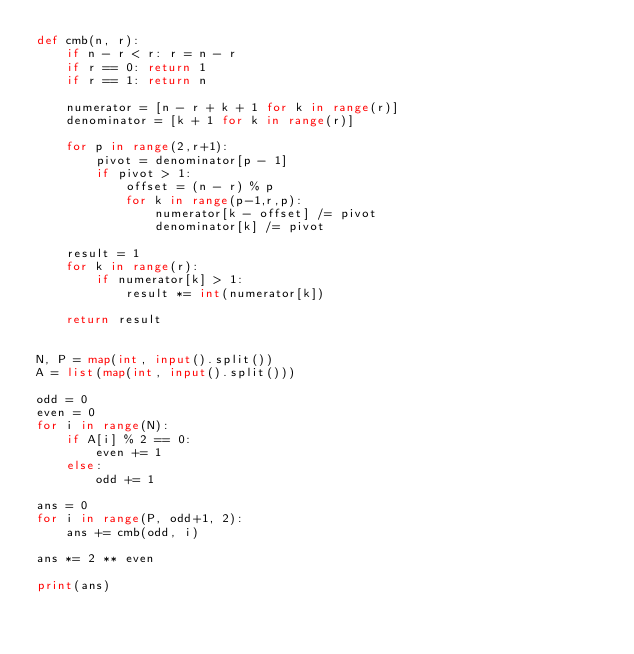Convert code to text. <code><loc_0><loc_0><loc_500><loc_500><_Python_>def cmb(n, r):
    if n - r < r: r = n - r
    if r == 0: return 1
    if r == 1: return n

    numerator = [n - r + k + 1 for k in range(r)]
    denominator = [k + 1 for k in range(r)]

    for p in range(2,r+1):
        pivot = denominator[p - 1]
        if pivot > 1:
            offset = (n - r) % p
            for k in range(p-1,r,p):
                numerator[k - offset] /= pivot
                denominator[k] /= pivot

    result = 1
    for k in range(r):
        if numerator[k] > 1:
            result *= int(numerator[k])

    return result


N, P = map(int, input().split())
A = list(map(int, input().split()))

odd = 0
even = 0
for i in range(N):
    if A[i] % 2 == 0:
        even += 1
    else:
        odd += 1
        
ans = 0
for i in range(P, odd+1, 2):
    ans += cmb(odd, i)
    
ans *= 2 ** even

print(ans)</code> 